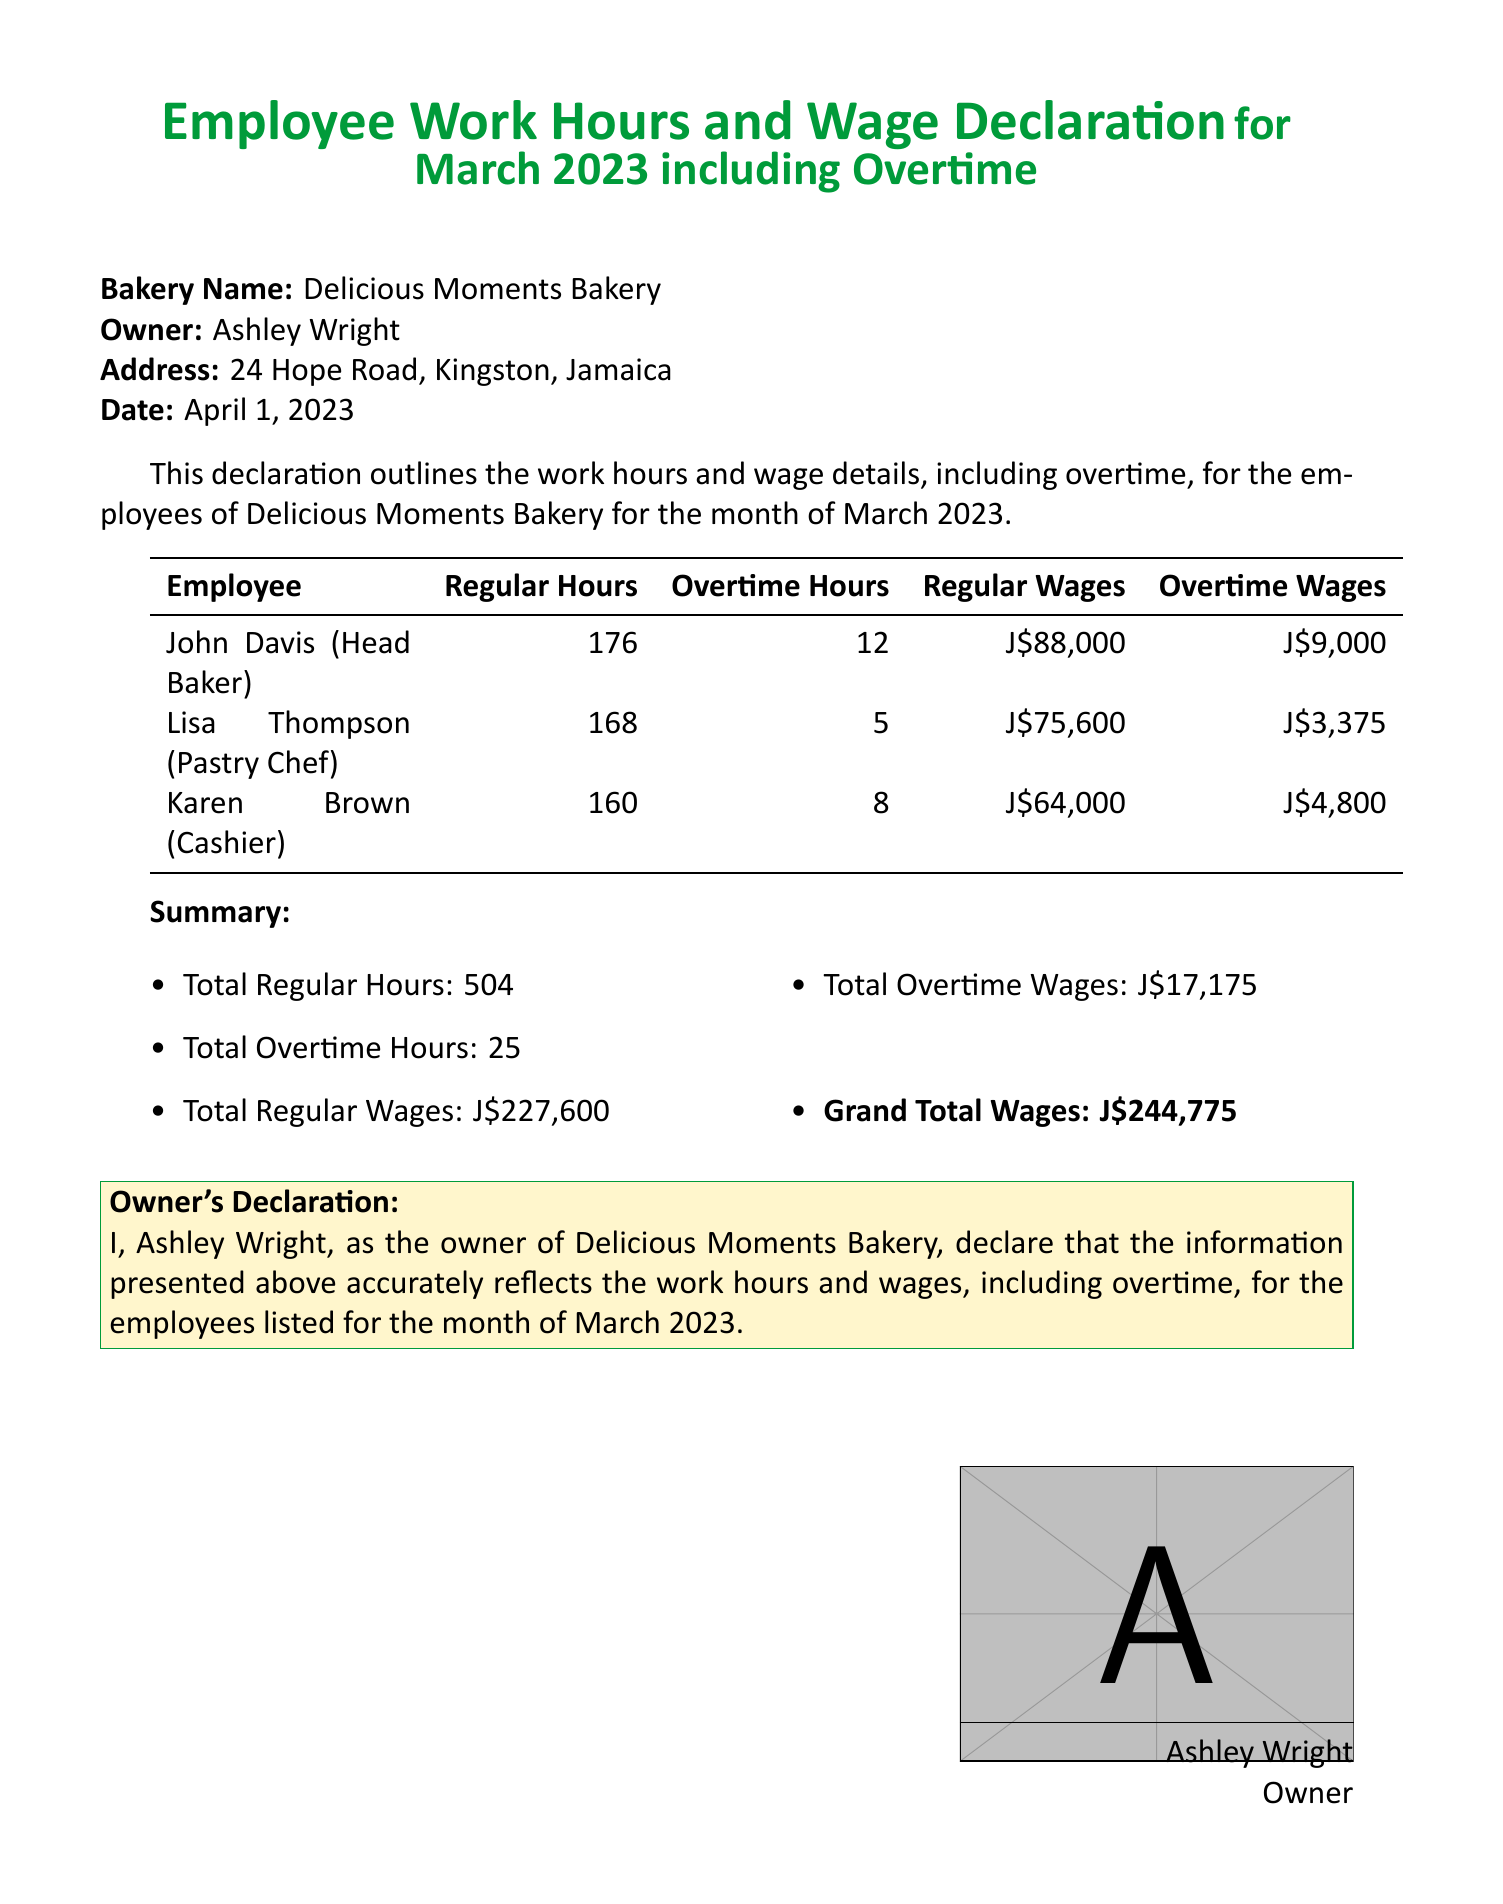What is the name of the bakery? The name of the bakery is stated in the document header as "Delicious Moments Bakery."
Answer: Delicious Moments Bakery Who is the owner of the bakery? The document clearly states the owner's name as "Ashley Wright."
Answer: Ashley Wright What is the total regular wages paid for March 2023? The total regular wages is the sum of wages listed for each employee, which is J$88,000 + J$75,600 + J$64,000.
Answer: J$227,600 How many overtime hours did Karen Brown work? The document lists Karen Brown's overtime hours as 8 hours.
Answer: 8 What is the grand total wages for March 2023? The grand total wages is highlighted at the end of the document as "J$244,775."
Answer: J$244,775 What is the total number of employees listed? The number of employees can be counted from the table in the document, which lists three employees.
Answer: 3 What is the address of the bakery? The bakery's address is provided in the document as "24 Hope Road, Kingston, Jamaica."
Answer: 24 Hope Road, Kingston, Jamaica How many total overtime hours were recorded? The document summarizes total overtime hours as 25 hours.
Answer: 25 What is the regular wage for Lisa Thompson? Lisa Thompson's regular wage is stated clearly in the table as "J$75,600."
Answer: J$75,600 